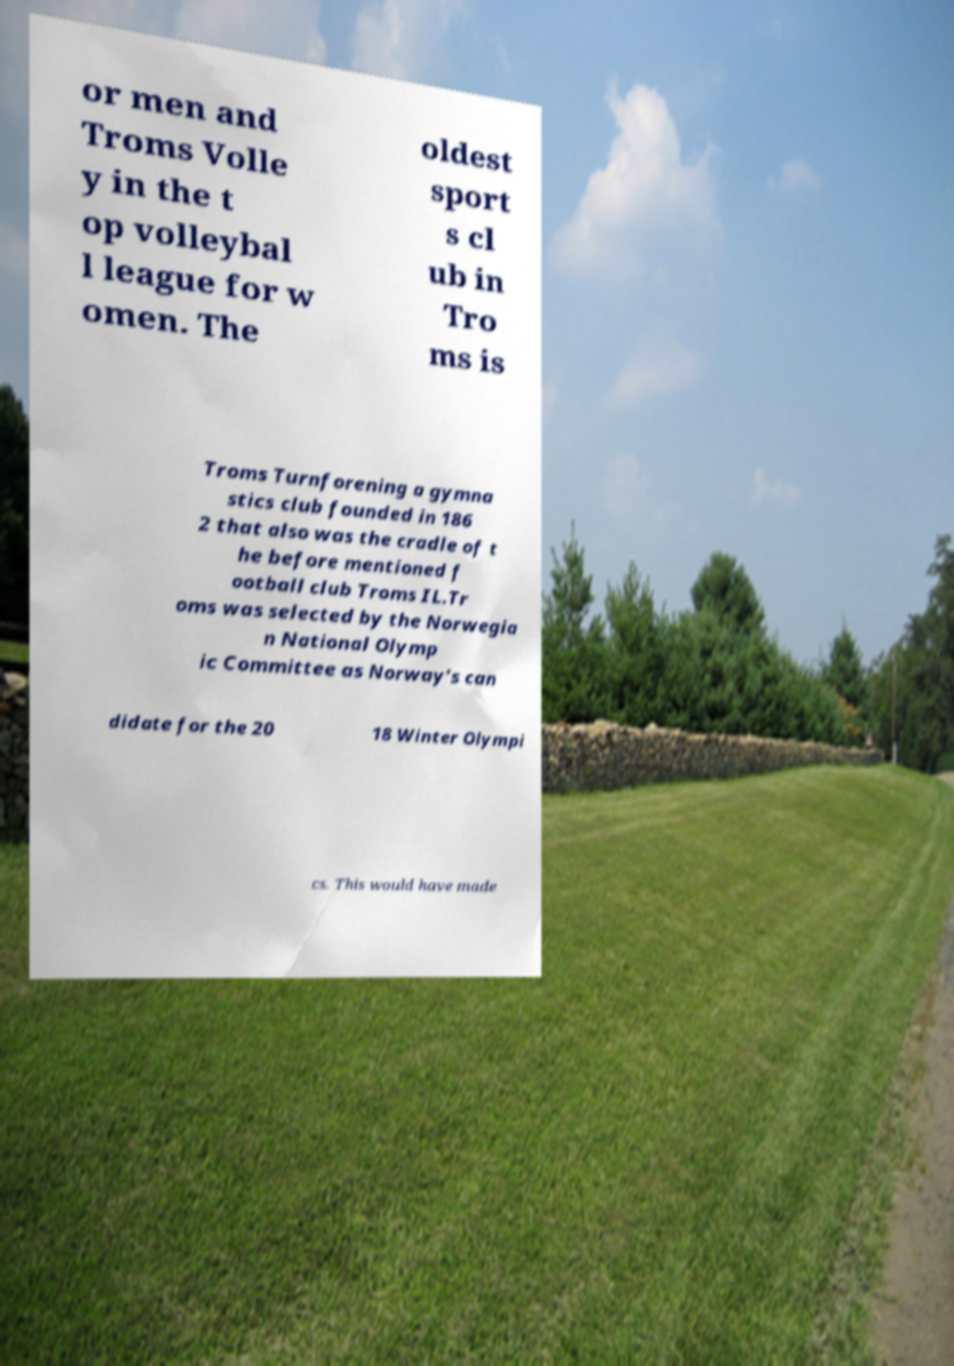Could you extract and type out the text from this image? or men and Troms Volle y in the t op volleybal l league for w omen. The oldest sport s cl ub in Tro ms is Troms Turnforening a gymna stics club founded in 186 2 that also was the cradle of t he before mentioned f ootball club Troms IL.Tr oms was selected by the Norwegia n National Olymp ic Committee as Norway's can didate for the 20 18 Winter Olympi cs. This would have made 